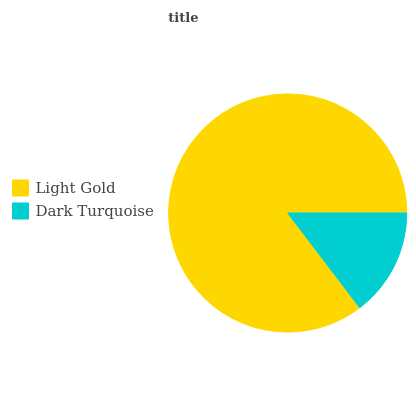Is Dark Turquoise the minimum?
Answer yes or no. Yes. Is Light Gold the maximum?
Answer yes or no. Yes. Is Dark Turquoise the maximum?
Answer yes or no. No. Is Light Gold greater than Dark Turquoise?
Answer yes or no. Yes. Is Dark Turquoise less than Light Gold?
Answer yes or no. Yes. Is Dark Turquoise greater than Light Gold?
Answer yes or no. No. Is Light Gold less than Dark Turquoise?
Answer yes or no. No. Is Light Gold the high median?
Answer yes or no. Yes. Is Dark Turquoise the low median?
Answer yes or no. Yes. Is Dark Turquoise the high median?
Answer yes or no. No. Is Light Gold the low median?
Answer yes or no. No. 